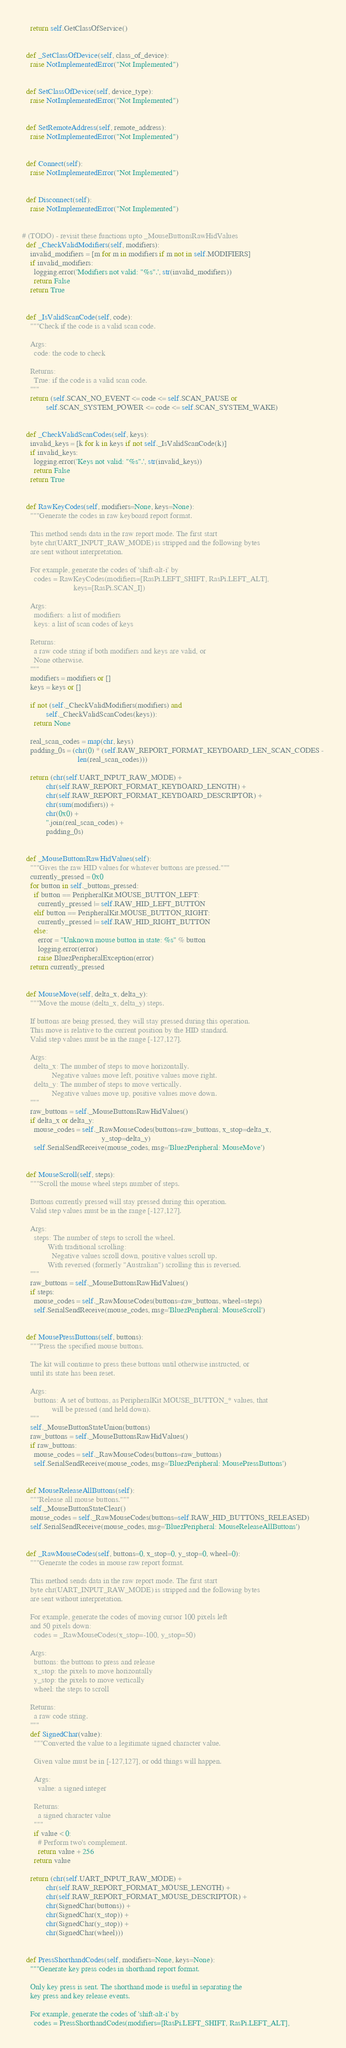Convert code to text. <code><loc_0><loc_0><loc_500><loc_500><_Python_>    return self.GetClassOfService()


  def _SetClassOfDevice(self, class_of_device):
    raise NotImplementedError("Not Implemented")


  def SetClassOfDevice(self, device_type):
    raise NotImplementedError("Not Implemented")


  def SetRemoteAddress(self, remote_address):
    raise NotImplementedError("Not Implemented")


  def Connect(self):
    raise NotImplementedError("Not Implemented")


  def Disconnect(self):
    raise NotImplementedError("Not Implemented")


# (TODO) - revisit these functions upto _MouseButtonsRawHidValues
  def _CheckValidModifiers(self, modifiers):
    invalid_modifiers = [m for m in modifiers if m not in self.MODIFIERS]
    if invalid_modifiers:
      logging.error('Modifiers not valid: "%s".', str(invalid_modifiers))
      return False
    return True


  def _IsValidScanCode(self, code):
    """Check if the code is a valid scan code.

    Args:
      code: the code to check

    Returns:
      True: if the code is a valid scan code.
    """
    return (self.SCAN_NO_EVENT <= code <= self.SCAN_PAUSE or
            self.SCAN_SYSTEM_POWER <= code <= self.SCAN_SYSTEM_WAKE)


  def _CheckValidScanCodes(self, keys):
    invalid_keys = [k for k in keys if not self._IsValidScanCode(k)]
    if invalid_keys:
      logging.error('Keys not valid: "%s".', str(invalid_keys))
      return False
    return True


  def RawKeyCodes(self, modifiers=None, keys=None):
    """Generate the codes in raw keyboard report format.

    This method sends data in the raw report mode. The first start
    byte chr(UART_INPUT_RAW_MODE) is stripped and the following bytes
    are sent without interpretation.

    For example, generate the codes of 'shift-alt-i' by
      codes = RawKeyCodes(modifiers=[RasPi.LEFT_SHIFT, RasPi.LEFT_ALT],
                          keys=[RasPi.SCAN_I])

    Args:
      modifiers: a list of modifiers
      keys: a list of scan codes of keys

    Returns:
      a raw code string if both modifiers and keys are valid, or
      None otherwise.
    """
    modifiers = modifiers or []
    keys = keys or []

    if not (self._CheckValidModifiers(modifiers) and
            self._CheckValidScanCodes(keys)):
      return None

    real_scan_codes = map(chr, keys)
    padding_0s = (chr(0) * (self.RAW_REPORT_FORMAT_KEYBOARD_LEN_SCAN_CODES -
                            len(real_scan_codes)))

    return (chr(self.UART_INPUT_RAW_MODE) +
            chr(self.RAW_REPORT_FORMAT_KEYBOARD_LENGTH) +
            chr(self.RAW_REPORT_FORMAT_KEYBOARD_DESCRIPTOR) +
            chr(sum(modifiers)) +
            chr(0x0) +
            ''.join(real_scan_codes) +
            padding_0s)


  def _MouseButtonsRawHidValues(self):
    """Gives the raw HID values for whatever buttons are pressed."""
    currently_pressed = 0x0
    for button in self._buttons_pressed:
      if button == PeripheralKit.MOUSE_BUTTON_LEFT:
        currently_pressed |= self.RAW_HID_LEFT_BUTTON
      elif button == PeripheralKit.MOUSE_BUTTON_RIGHT:
        currently_pressed |= self.RAW_HID_RIGHT_BUTTON
      else:
        error = "Unknown mouse button in state: %s" % button
        logging.error(error)
        raise BluezPeripheralException(error)
    return currently_pressed


  def MouseMove(self, delta_x, delta_y):
    """Move the mouse (delta_x, delta_y) steps.

    If buttons are being pressed, they will stay pressed during this operation.
    This move is relative to the current position by the HID standard.
    Valid step values must be in the range [-127,127].

    Args:
      delta_x: The number of steps to move horizontally.
               Negative values move left, positive values move right.
      delta_y: The number of steps to move vertically.
               Negative values move up, positive values move down.
    """
    raw_buttons = self._MouseButtonsRawHidValues()
    if delta_x or delta_y:
      mouse_codes = self._RawMouseCodes(buttons=raw_buttons, x_stop=delta_x,
                                        y_stop=delta_y)
      self.SerialSendReceive(mouse_codes, msg='BluezPeripheral: MouseMove')


  def MouseScroll(self, steps):
    """Scroll the mouse wheel steps number of steps.

    Buttons currently pressed will stay pressed during this operation.
    Valid step values must be in the range [-127,127].

    Args:
      steps: The number of steps to scroll the wheel.
             With traditional scrolling:
               Negative values scroll down, positive values scroll up.
             With reversed (formerly "Australian") scrolling this is reversed.
    """
    raw_buttons = self._MouseButtonsRawHidValues()
    if steps:
      mouse_codes = self._RawMouseCodes(buttons=raw_buttons, wheel=steps)
      self.SerialSendReceive(mouse_codes, msg='BluezPeripheral: MouseScroll')


  def MousePressButtons(self, buttons):
    """Press the specified mouse buttons.

    The kit will continue to press these buttons until otherwise instructed, or
    until its state has been reset.

    Args:
      buttons: A set of buttons, as PeripheralKit MOUSE_BUTTON_* values, that
               will be pressed (and held down).
    """
    self._MouseButtonStateUnion(buttons)
    raw_buttons = self._MouseButtonsRawHidValues()
    if raw_buttons:
      mouse_codes = self._RawMouseCodes(buttons=raw_buttons)
      self.SerialSendReceive(mouse_codes, msg='BluezPeripheral: MousePressButtons')


  def MouseReleaseAllButtons(self):
    """Release all mouse buttons."""
    self._MouseButtonStateClear()
    mouse_codes = self._RawMouseCodes(buttons=self.RAW_HID_BUTTONS_RELEASED)
    self.SerialSendReceive(mouse_codes, msg='BluezPeripheral: MouseReleaseAllButtons')


  def _RawMouseCodes(self, buttons=0, x_stop=0, y_stop=0, wheel=0):
    """Generate the codes in mouse raw report format.

    This method sends data in the raw report mode. The first start
    byte chr(UART_INPUT_RAW_MODE) is stripped and the following bytes
    are sent without interpretation.

    For example, generate the codes of moving cursor 100 pixels left
    and 50 pixels down:
      codes = _RawMouseCodes(x_stop=-100, y_stop=50)

    Args:
      buttons: the buttons to press and release
      x_stop: the pixels to move horizontally
      y_stop: the pixels to move vertically
      wheel: the steps to scroll

    Returns:
      a raw code string.
    """
    def SignedChar(value):
      """Converted the value to a legitimate signed character value.

      Given value must be in [-127,127], or odd things will happen.

      Args:
        value: a signed integer

      Returns:
        a signed character value
      """
      if value < 0:
        # Perform two's complement.
        return value + 256
      return value

    return (chr(self.UART_INPUT_RAW_MODE) +
            chr(self.RAW_REPORT_FORMAT_MOUSE_LENGTH) +
            chr(self.RAW_REPORT_FORMAT_MOUSE_DESCRIPTOR) +
            chr(SignedChar(buttons)) +
            chr(SignedChar(x_stop)) +
            chr(SignedChar(y_stop)) +
            chr(SignedChar(wheel)))


  def PressShorthandCodes(self, modifiers=None, keys=None):
    """Generate key press codes in shorthand report format.

    Only key press is sent. The shorthand mode is useful in separating the
    key press and key release events.

    For example, generate the codes of 'shift-alt-i' by
      codes = PressShorthandCodes(modifiers=[RasPi.LEFT_SHIFT, RasPi.LEFT_ALT],</code> 